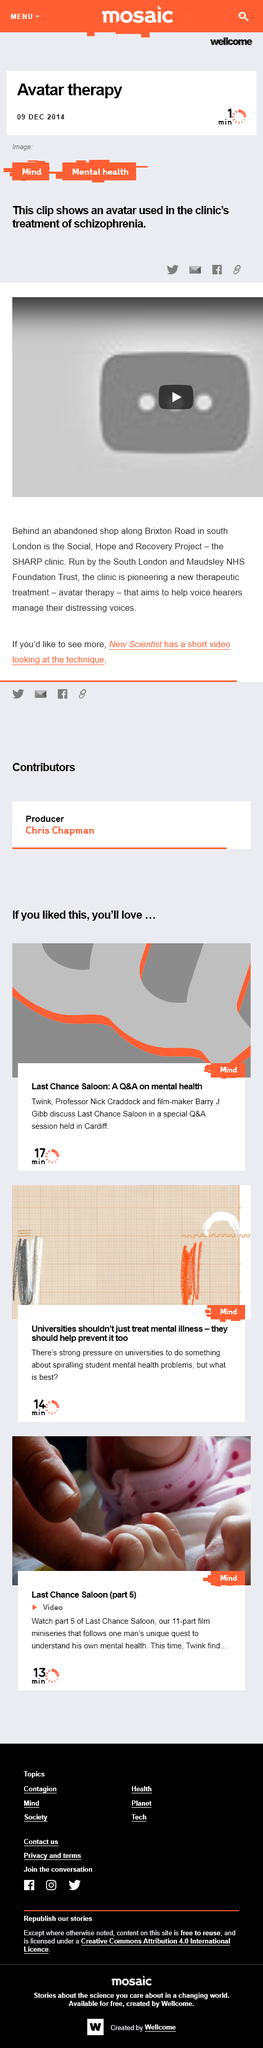Indicate a few pertinent items in this graphic. The miniseries explores the journey of an individual as he embarks on a personal quest to comprehend his own mental well-being. The film comprises 11 distinct parts that must be watched in their entirety to understand the story. Professor Nick Craddock and film-maker Barry Gibb are hosting a special session Q&A in Cardiff. 